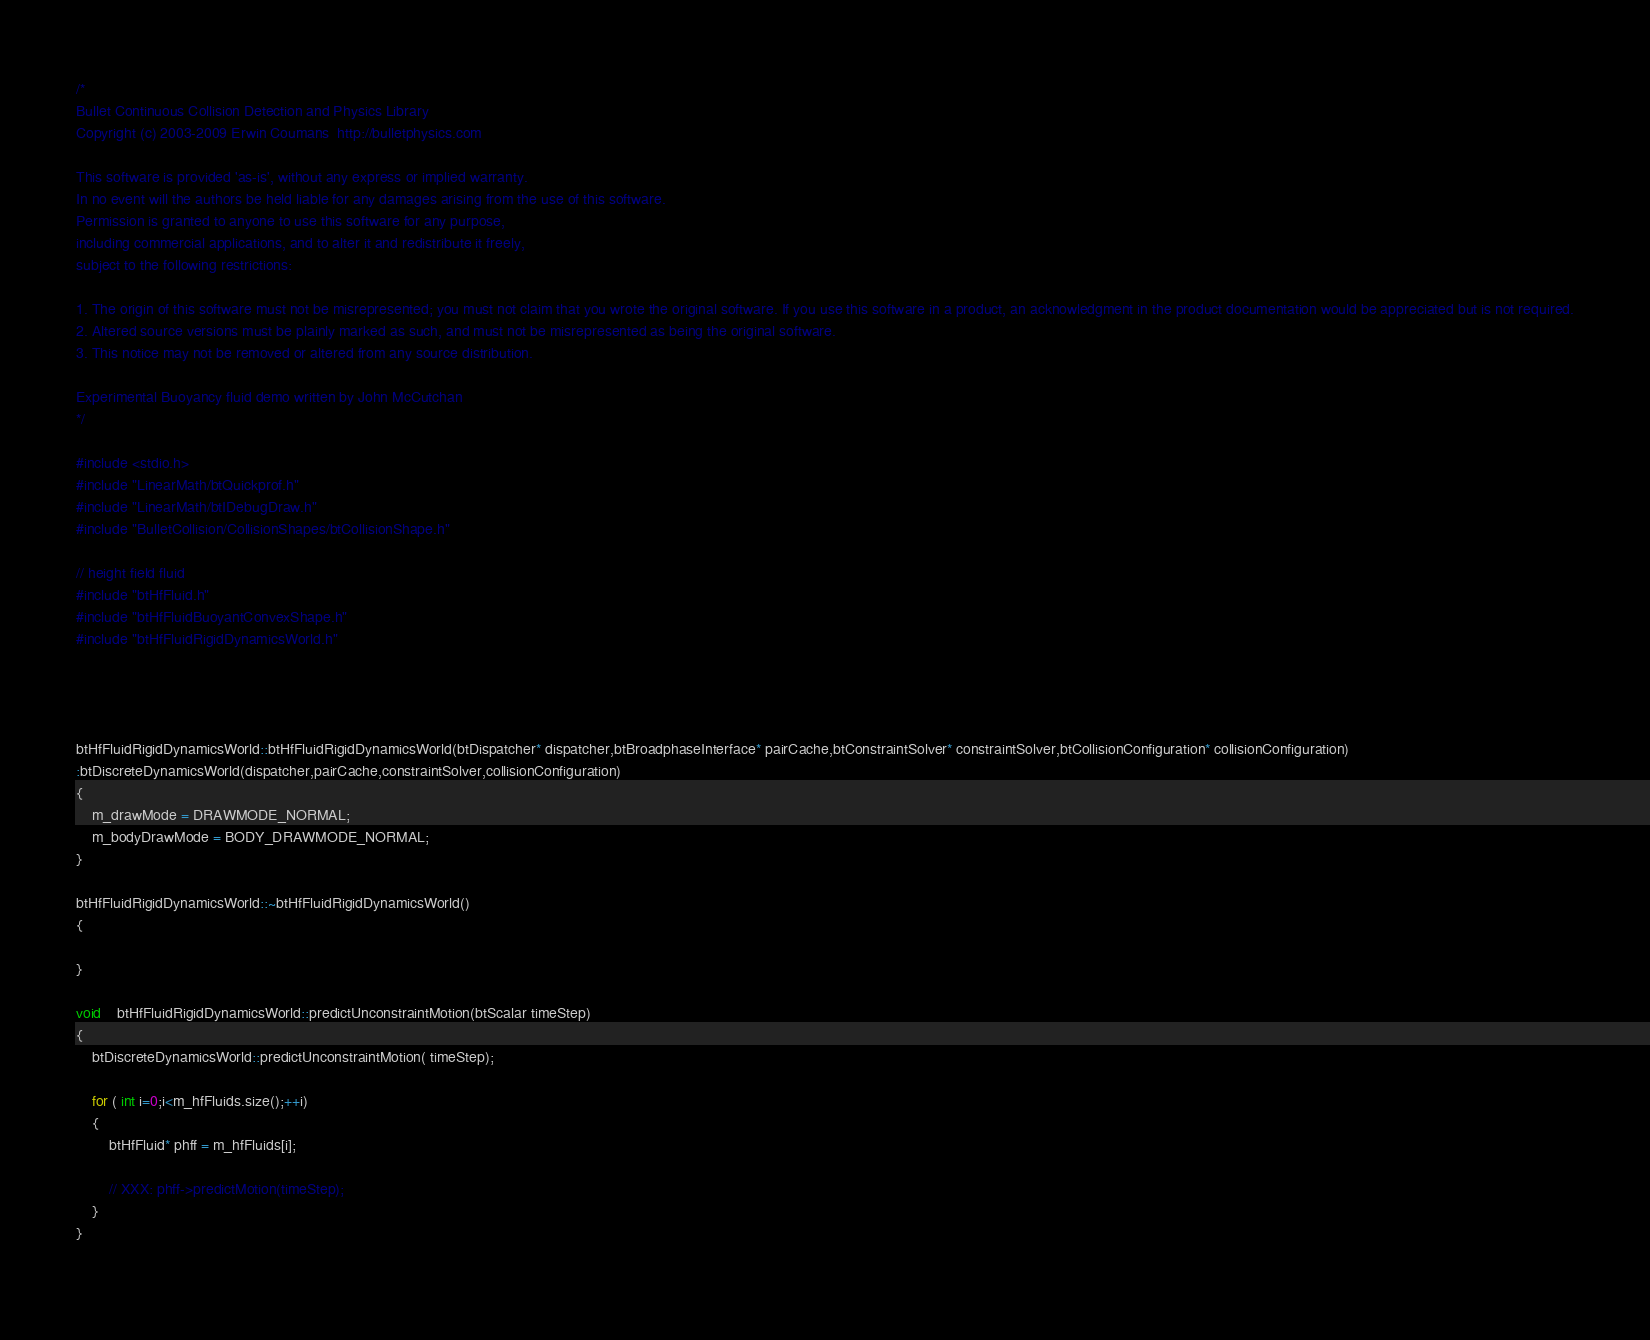<code> <loc_0><loc_0><loc_500><loc_500><_C++_>/*
Bullet Continuous Collision Detection and Physics Library
Copyright (c) 2003-2009 Erwin Coumans  http://bulletphysics.com

This software is provided 'as-is', without any express or implied warranty.
In no event will the authors be held liable for any damages arising from the use of this software.
Permission is granted to anyone to use this software for any purpose, 
including commercial applications, and to alter it and redistribute it freely, 
subject to the following restrictions:

1. The origin of this software must not be misrepresented; you must not claim that you wrote the original software. If you use this software in a product, an acknowledgment in the product documentation would be appreciated but is not required.
2. Altered source versions must be plainly marked as such, and must not be misrepresented as being the original software.
3. This notice may not be removed or altered from any source distribution.

Experimental Buoyancy fluid demo written by John McCutchan
*/

#include <stdio.h>
#include "LinearMath/btQuickprof.h"
#include "LinearMath/btIDebugDraw.h"
#include "BulletCollision/CollisionShapes/btCollisionShape.h"

// height field fluid
#include "btHfFluid.h"
#include "btHfFluidBuoyantConvexShape.h"
#include "btHfFluidRigidDynamicsWorld.h"




btHfFluidRigidDynamicsWorld::btHfFluidRigidDynamicsWorld(btDispatcher* dispatcher,btBroadphaseInterface* pairCache,btConstraintSolver* constraintSolver,btCollisionConfiguration* collisionConfiguration)
:btDiscreteDynamicsWorld(dispatcher,pairCache,constraintSolver,collisionConfiguration)
{
	m_drawMode = DRAWMODE_NORMAL;
	m_bodyDrawMode = BODY_DRAWMODE_NORMAL;
}
		
btHfFluidRigidDynamicsWorld::~btHfFluidRigidDynamicsWorld()
{

}

void	btHfFluidRigidDynamicsWorld::predictUnconstraintMotion(btScalar timeStep)
{
	btDiscreteDynamicsWorld::predictUnconstraintMotion( timeStep);

	for ( int i=0;i<m_hfFluids.size();++i)
	{
		btHfFluid* phff = m_hfFluids[i];

		// XXX: phff->predictMotion(timeStep);		
	}
}
		</code> 